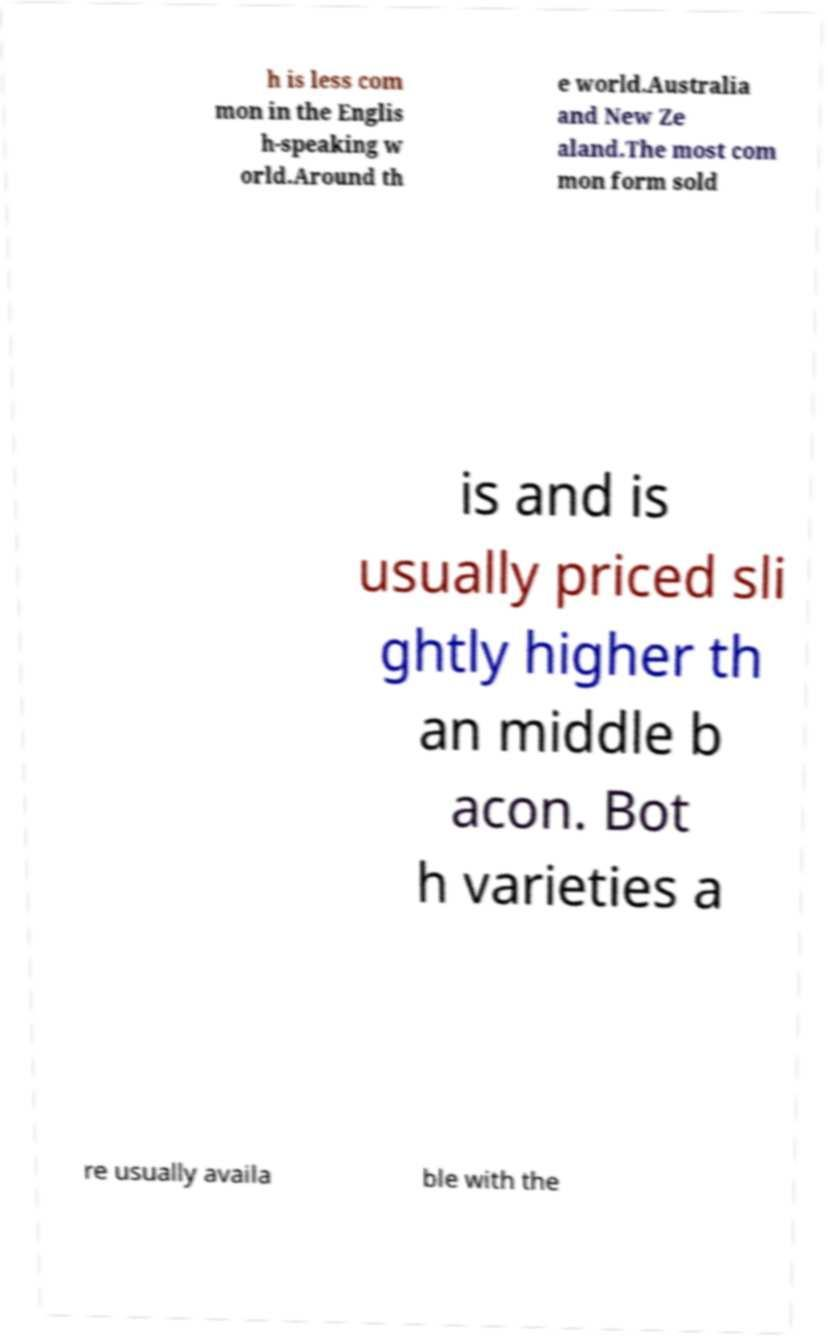Could you extract and type out the text from this image? h is less com mon in the Englis h-speaking w orld.Around th e world.Australia and New Ze aland.The most com mon form sold is and is usually priced sli ghtly higher th an middle b acon. Bot h varieties a re usually availa ble with the 